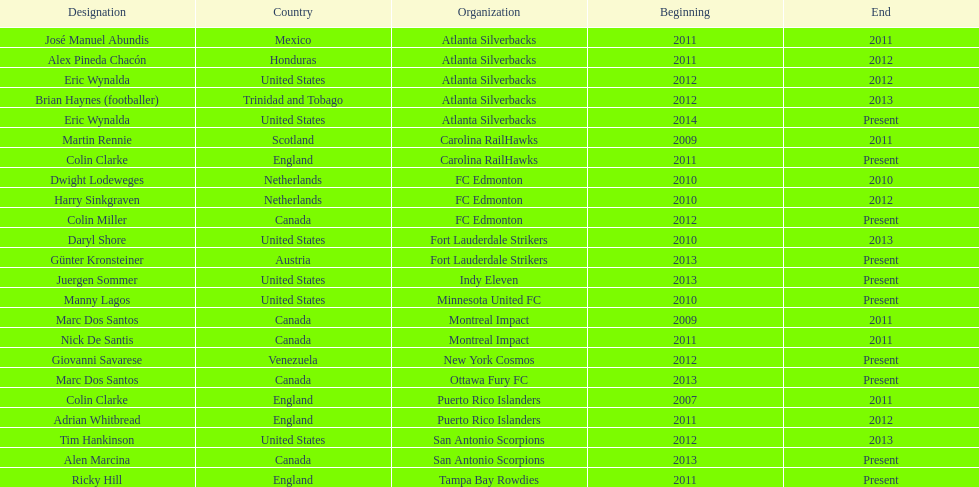Who coached the silverbacks longer, abundis or chacon? Chacon. 